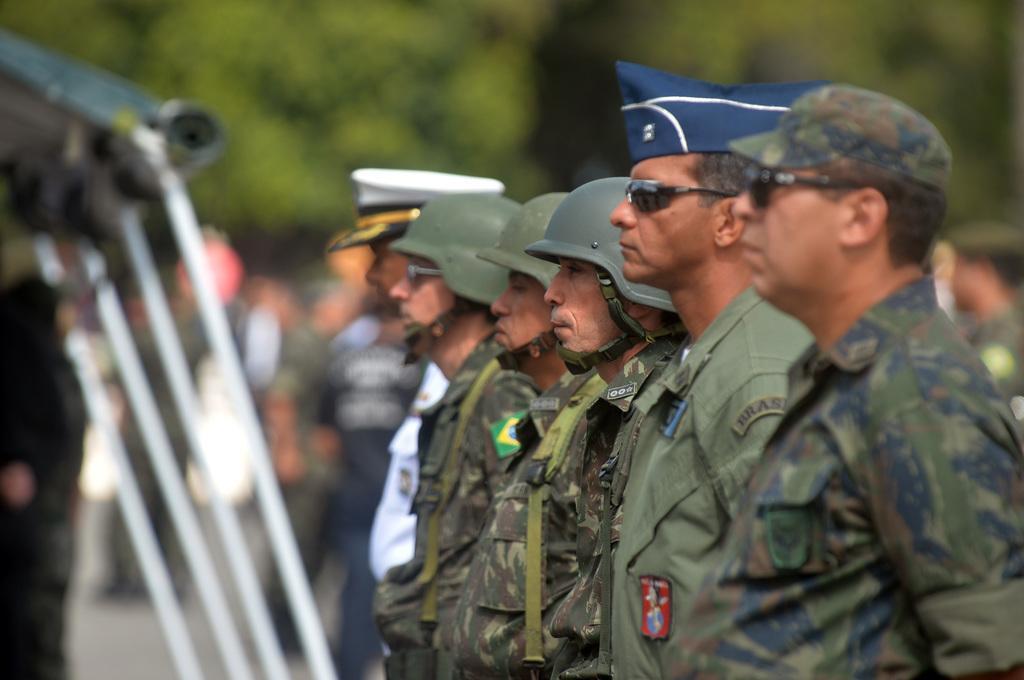Please provide a concise description of this image. There are few persons standing and they have caps on their heads. On the left there are poles and objects. In the background the image is blur but we can see few persons are standing on the road and trees. 